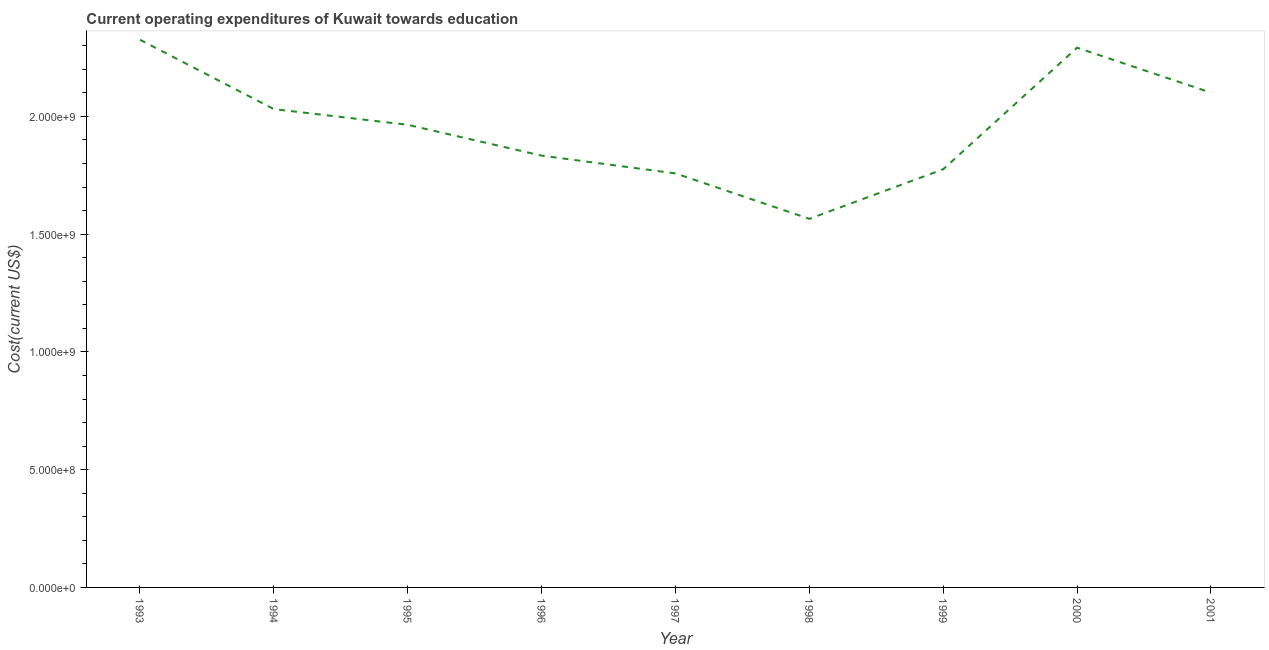What is the education expenditure in 1993?
Your answer should be very brief. 2.33e+09. Across all years, what is the maximum education expenditure?
Keep it short and to the point. 2.33e+09. Across all years, what is the minimum education expenditure?
Your answer should be very brief. 1.57e+09. What is the sum of the education expenditure?
Provide a succinct answer. 1.76e+1. What is the difference between the education expenditure in 1993 and 1997?
Give a very brief answer. 5.67e+08. What is the average education expenditure per year?
Make the answer very short. 1.96e+09. What is the median education expenditure?
Give a very brief answer. 1.96e+09. What is the ratio of the education expenditure in 1996 to that in 1998?
Your answer should be very brief. 1.17. Is the difference between the education expenditure in 1997 and 1998 greater than the difference between any two years?
Provide a short and direct response. No. What is the difference between the highest and the second highest education expenditure?
Keep it short and to the point. 3.37e+07. Is the sum of the education expenditure in 1998 and 1999 greater than the maximum education expenditure across all years?
Give a very brief answer. Yes. What is the difference between the highest and the lowest education expenditure?
Offer a very short reply. 7.60e+08. How many lines are there?
Offer a very short reply. 1. Are the values on the major ticks of Y-axis written in scientific E-notation?
Ensure brevity in your answer.  Yes. Does the graph contain grids?
Your response must be concise. No. What is the title of the graph?
Ensure brevity in your answer.  Current operating expenditures of Kuwait towards education. What is the label or title of the Y-axis?
Make the answer very short. Cost(current US$). What is the Cost(current US$) in 1993?
Your answer should be compact. 2.33e+09. What is the Cost(current US$) of 1994?
Ensure brevity in your answer.  2.03e+09. What is the Cost(current US$) in 1995?
Your response must be concise. 1.96e+09. What is the Cost(current US$) of 1996?
Keep it short and to the point. 1.83e+09. What is the Cost(current US$) of 1997?
Provide a short and direct response. 1.76e+09. What is the Cost(current US$) in 1998?
Your answer should be very brief. 1.57e+09. What is the Cost(current US$) in 1999?
Provide a succinct answer. 1.78e+09. What is the Cost(current US$) of 2000?
Provide a succinct answer. 2.29e+09. What is the Cost(current US$) of 2001?
Your answer should be very brief. 2.10e+09. What is the difference between the Cost(current US$) in 1993 and 1994?
Keep it short and to the point. 2.94e+08. What is the difference between the Cost(current US$) in 1993 and 1995?
Make the answer very short. 3.61e+08. What is the difference between the Cost(current US$) in 1993 and 1996?
Offer a terse response. 4.92e+08. What is the difference between the Cost(current US$) in 1993 and 1997?
Provide a succinct answer. 5.67e+08. What is the difference between the Cost(current US$) in 1993 and 1998?
Ensure brevity in your answer.  7.60e+08. What is the difference between the Cost(current US$) in 1993 and 1999?
Give a very brief answer. 5.50e+08. What is the difference between the Cost(current US$) in 1993 and 2000?
Your response must be concise. 3.37e+07. What is the difference between the Cost(current US$) in 1993 and 2001?
Make the answer very short. 2.25e+08. What is the difference between the Cost(current US$) in 1994 and 1995?
Provide a succinct answer. 6.67e+07. What is the difference between the Cost(current US$) in 1994 and 1996?
Keep it short and to the point. 1.98e+08. What is the difference between the Cost(current US$) in 1994 and 1997?
Your response must be concise. 2.73e+08. What is the difference between the Cost(current US$) in 1994 and 1998?
Offer a terse response. 4.66e+08. What is the difference between the Cost(current US$) in 1994 and 1999?
Ensure brevity in your answer.  2.56e+08. What is the difference between the Cost(current US$) in 1994 and 2000?
Give a very brief answer. -2.61e+08. What is the difference between the Cost(current US$) in 1994 and 2001?
Ensure brevity in your answer.  -6.98e+07. What is the difference between the Cost(current US$) in 1995 and 1996?
Provide a succinct answer. 1.31e+08. What is the difference between the Cost(current US$) in 1995 and 1997?
Provide a succinct answer. 2.06e+08. What is the difference between the Cost(current US$) in 1995 and 1998?
Provide a short and direct response. 3.99e+08. What is the difference between the Cost(current US$) in 1995 and 1999?
Offer a terse response. 1.89e+08. What is the difference between the Cost(current US$) in 1995 and 2000?
Your answer should be very brief. -3.27e+08. What is the difference between the Cost(current US$) in 1995 and 2001?
Make the answer very short. -1.36e+08. What is the difference between the Cost(current US$) in 1996 and 1997?
Keep it short and to the point. 7.54e+07. What is the difference between the Cost(current US$) in 1996 and 1998?
Offer a very short reply. 2.68e+08. What is the difference between the Cost(current US$) in 1996 and 1999?
Your response must be concise. 5.79e+07. What is the difference between the Cost(current US$) in 1996 and 2000?
Provide a short and direct response. -4.58e+08. What is the difference between the Cost(current US$) in 1996 and 2001?
Provide a short and direct response. -2.67e+08. What is the difference between the Cost(current US$) in 1997 and 1998?
Make the answer very short. 1.93e+08. What is the difference between the Cost(current US$) in 1997 and 1999?
Make the answer very short. -1.75e+07. What is the difference between the Cost(current US$) in 1997 and 2000?
Your answer should be very brief. -5.34e+08. What is the difference between the Cost(current US$) in 1997 and 2001?
Offer a very short reply. -3.43e+08. What is the difference between the Cost(current US$) in 1998 and 1999?
Ensure brevity in your answer.  -2.10e+08. What is the difference between the Cost(current US$) in 1998 and 2000?
Your answer should be very brief. -7.27e+08. What is the difference between the Cost(current US$) in 1998 and 2001?
Your answer should be very brief. -5.36e+08. What is the difference between the Cost(current US$) in 1999 and 2000?
Your response must be concise. -5.16e+08. What is the difference between the Cost(current US$) in 1999 and 2001?
Your answer should be compact. -3.25e+08. What is the difference between the Cost(current US$) in 2000 and 2001?
Offer a very short reply. 1.91e+08. What is the ratio of the Cost(current US$) in 1993 to that in 1994?
Offer a very short reply. 1.15. What is the ratio of the Cost(current US$) in 1993 to that in 1995?
Offer a very short reply. 1.18. What is the ratio of the Cost(current US$) in 1993 to that in 1996?
Your response must be concise. 1.27. What is the ratio of the Cost(current US$) in 1993 to that in 1997?
Make the answer very short. 1.32. What is the ratio of the Cost(current US$) in 1993 to that in 1998?
Your answer should be compact. 1.49. What is the ratio of the Cost(current US$) in 1993 to that in 1999?
Give a very brief answer. 1.31. What is the ratio of the Cost(current US$) in 1993 to that in 2000?
Offer a terse response. 1.01. What is the ratio of the Cost(current US$) in 1993 to that in 2001?
Offer a terse response. 1.11. What is the ratio of the Cost(current US$) in 1994 to that in 1995?
Your response must be concise. 1.03. What is the ratio of the Cost(current US$) in 1994 to that in 1996?
Your answer should be very brief. 1.11. What is the ratio of the Cost(current US$) in 1994 to that in 1997?
Keep it short and to the point. 1.16. What is the ratio of the Cost(current US$) in 1994 to that in 1998?
Your answer should be very brief. 1.3. What is the ratio of the Cost(current US$) in 1994 to that in 1999?
Provide a succinct answer. 1.14. What is the ratio of the Cost(current US$) in 1994 to that in 2000?
Offer a terse response. 0.89. What is the ratio of the Cost(current US$) in 1994 to that in 2001?
Provide a succinct answer. 0.97. What is the ratio of the Cost(current US$) in 1995 to that in 1996?
Make the answer very short. 1.07. What is the ratio of the Cost(current US$) in 1995 to that in 1997?
Ensure brevity in your answer.  1.12. What is the ratio of the Cost(current US$) in 1995 to that in 1998?
Keep it short and to the point. 1.25. What is the ratio of the Cost(current US$) in 1995 to that in 1999?
Your answer should be very brief. 1.11. What is the ratio of the Cost(current US$) in 1995 to that in 2000?
Offer a terse response. 0.86. What is the ratio of the Cost(current US$) in 1995 to that in 2001?
Offer a very short reply. 0.94. What is the ratio of the Cost(current US$) in 1996 to that in 1997?
Your answer should be very brief. 1.04. What is the ratio of the Cost(current US$) in 1996 to that in 1998?
Offer a very short reply. 1.17. What is the ratio of the Cost(current US$) in 1996 to that in 1999?
Your response must be concise. 1.03. What is the ratio of the Cost(current US$) in 1996 to that in 2001?
Offer a very short reply. 0.87. What is the ratio of the Cost(current US$) in 1997 to that in 1998?
Your answer should be very brief. 1.12. What is the ratio of the Cost(current US$) in 1997 to that in 2000?
Provide a succinct answer. 0.77. What is the ratio of the Cost(current US$) in 1997 to that in 2001?
Offer a terse response. 0.84. What is the ratio of the Cost(current US$) in 1998 to that in 1999?
Give a very brief answer. 0.88. What is the ratio of the Cost(current US$) in 1998 to that in 2000?
Your response must be concise. 0.68. What is the ratio of the Cost(current US$) in 1998 to that in 2001?
Keep it short and to the point. 0.74. What is the ratio of the Cost(current US$) in 1999 to that in 2000?
Offer a terse response. 0.78. What is the ratio of the Cost(current US$) in 1999 to that in 2001?
Provide a succinct answer. 0.84. What is the ratio of the Cost(current US$) in 2000 to that in 2001?
Your answer should be very brief. 1.09. 